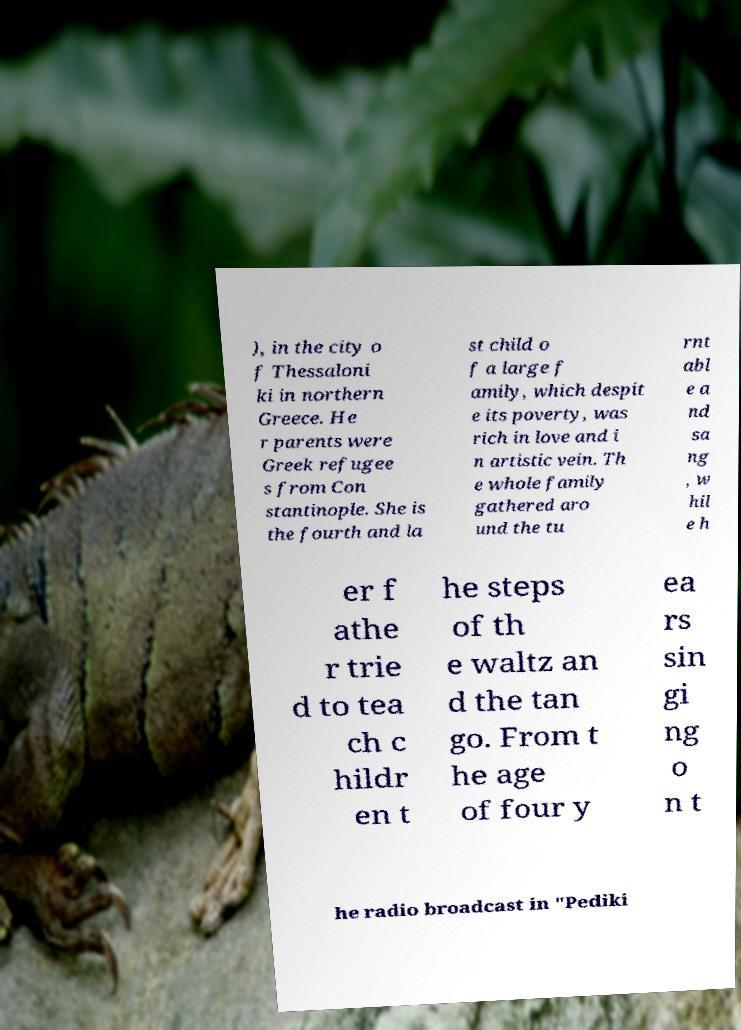Can you accurately transcribe the text from the provided image for me? ), in the city o f Thessaloni ki in northern Greece. He r parents were Greek refugee s from Con stantinople. She is the fourth and la st child o f a large f amily, which despit e its poverty, was rich in love and i n artistic vein. Th e whole family gathered aro und the tu rnt abl e a nd sa ng , w hil e h er f athe r trie d to tea ch c hildr en t he steps of th e waltz an d the tan go. From t he age of four y ea rs sin gi ng o n t he radio broadcast in "Pediki 